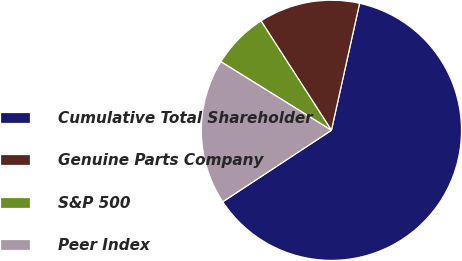<chart> <loc_0><loc_0><loc_500><loc_500><pie_chart><fcel>Cumulative Total Shareholder<fcel>Genuine Parts Company<fcel>S&P 500<fcel>Peer Index<nl><fcel>62.27%<fcel>12.58%<fcel>7.06%<fcel>18.1%<nl></chart> 